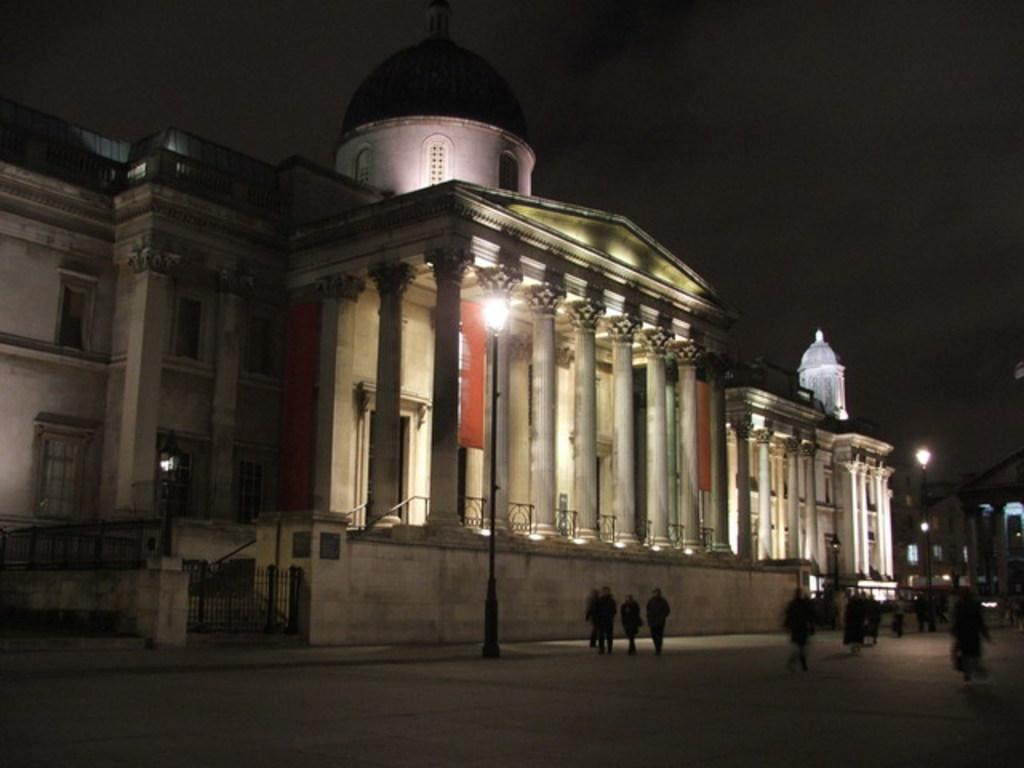What type of structure is visible in the image? There is a building in the image. What architectural features can be seen on the building? The building has arches and pillars. What else is present in the image besides the building? There are poles, trees, and people in the image. What is the profit margin of the porter in the image? There is no porter present in the image, and therefore no profit margin can be determined. 